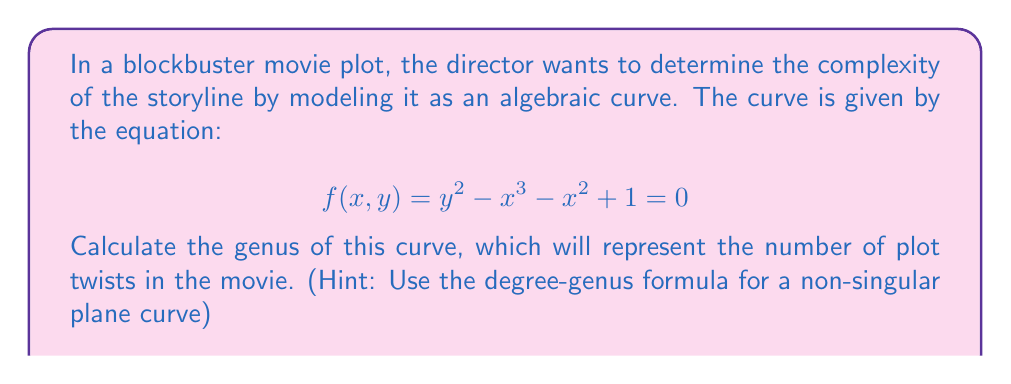Could you help me with this problem? Let's approach this step-by-step, like crafting a movie script:

1) First, we need to identify the degree of the curve. The degree is the highest sum of exponents in any term. Here, it's 3 (from the $x^3$ term).

2) For a non-singular plane curve of degree $d$, the genus $g$ is given by the formula:

   $$ g = \frac{(d-1)(d-2)}{2} $$

3) In our case, $d = 3$, so let's plug this into our formula:

   $$ g = \frac{(3-1)(3-2)}{2} $$

4) Simplify:
   $$ g = \frac{2 \cdot 1}{2} = 1 $$

5) Therefore, the genus of the curve is 1.

In movie terms, this means our plot has one major twist or complication, making it more intricate than a straightforward narrative (genus 0) but not as convoluted as a multi-layered thriller (genus > 1).
Answer: $1$ 